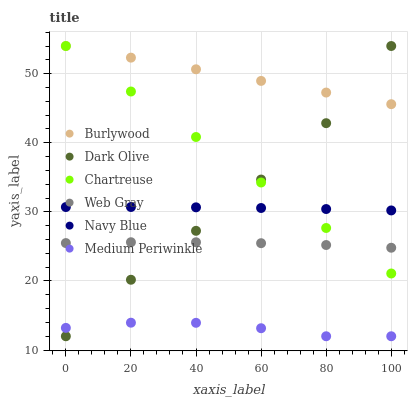Does Medium Periwinkle have the minimum area under the curve?
Answer yes or no. Yes. Does Burlywood have the maximum area under the curve?
Answer yes or no. Yes. Does Navy Blue have the minimum area under the curve?
Answer yes or no. No. Does Navy Blue have the maximum area under the curve?
Answer yes or no. No. Is Chartreuse the smoothest?
Answer yes or no. Yes. Is Dark Olive the roughest?
Answer yes or no. Yes. Is Burlywood the smoothest?
Answer yes or no. No. Is Burlywood the roughest?
Answer yes or no. No. Does Dark Olive have the lowest value?
Answer yes or no. Yes. Does Navy Blue have the lowest value?
Answer yes or no. No. Does Chartreuse have the highest value?
Answer yes or no. Yes. Does Navy Blue have the highest value?
Answer yes or no. No. Is Navy Blue less than Burlywood?
Answer yes or no. Yes. Is Chartreuse greater than Medium Periwinkle?
Answer yes or no. Yes. Does Burlywood intersect Dark Olive?
Answer yes or no. Yes. Is Burlywood less than Dark Olive?
Answer yes or no. No. Is Burlywood greater than Dark Olive?
Answer yes or no. No. Does Navy Blue intersect Burlywood?
Answer yes or no. No. 